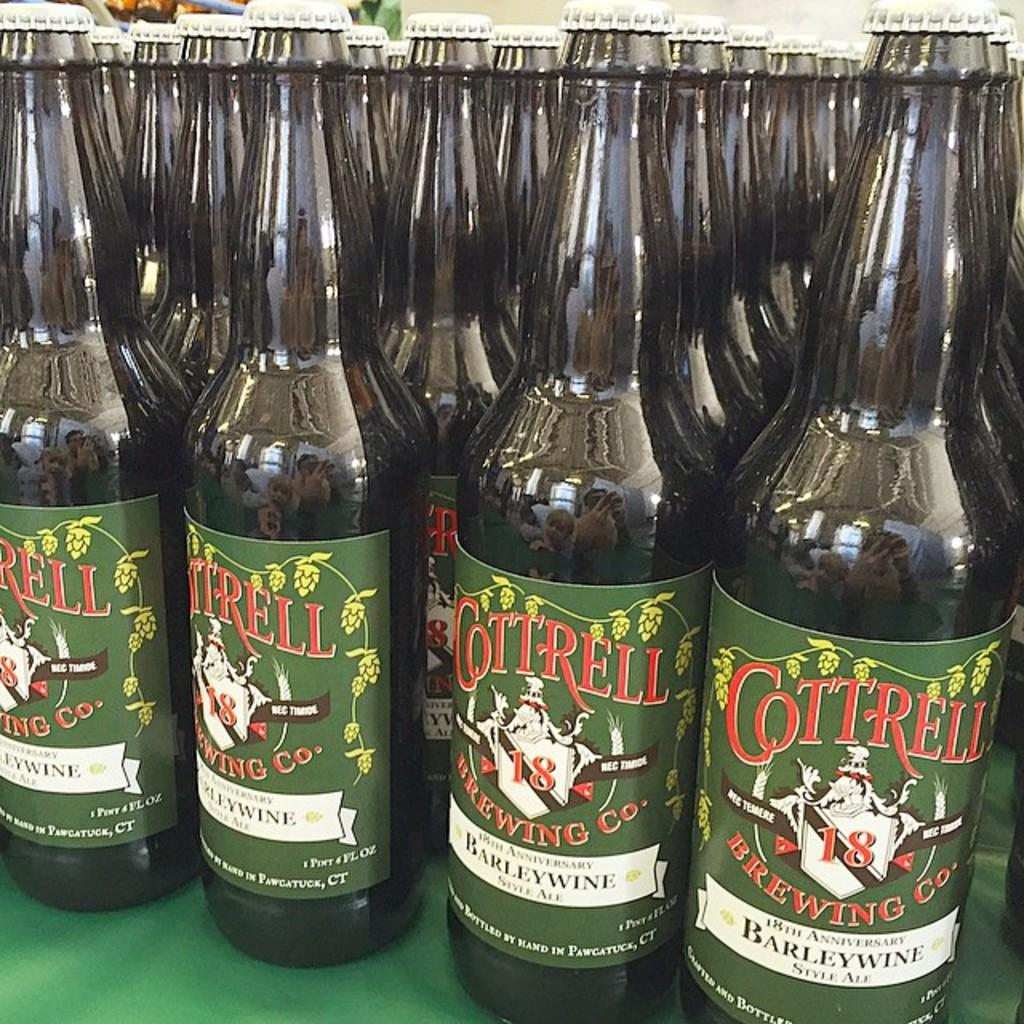<image>
Present a compact description of the photo's key features. Many bottles of Cottrell barleywine are sitting in neat rows. 